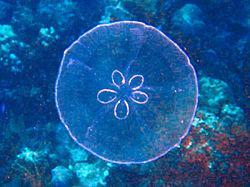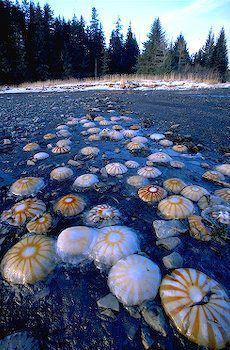The first image is the image on the left, the second image is the image on the right. For the images displayed, is the sentence "The left image shows masses of light blue jellyfish viewed from above the water's surface, with a city horizon in the background." factually correct? Answer yes or no. No. The first image is the image on the left, the second image is the image on the right. Considering the images on both sides, is "there are many jellyfish being viewed from above water in daylight hours" valid? Answer yes or no. Yes. 